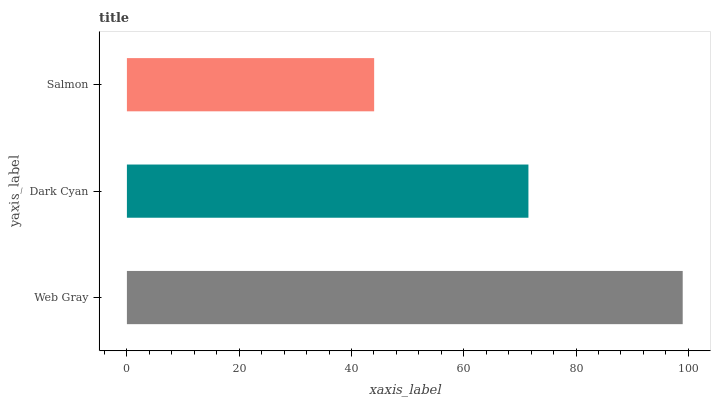Is Salmon the minimum?
Answer yes or no. Yes. Is Web Gray the maximum?
Answer yes or no. Yes. Is Dark Cyan the minimum?
Answer yes or no. No. Is Dark Cyan the maximum?
Answer yes or no. No. Is Web Gray greater than Dark Cyan?
Answer yes or no. Yes. Is Dark Cyan less than Web Gray?
Answer yes or no. Yes. Is Dark Cyan greater than Web Gray?
Answer yes or no. No. Is Web Gray less than Dark Cyan?
Answer yes or no. No. Is Dark Cyan the high median?
Answer yes or no. Yes. Is Dark Cyan the low median?
Answer yes or no. Yes. Is Salmon the high median?
Answer yes or no. No. Is Salmon the low median?
Answer yes or no. No. 